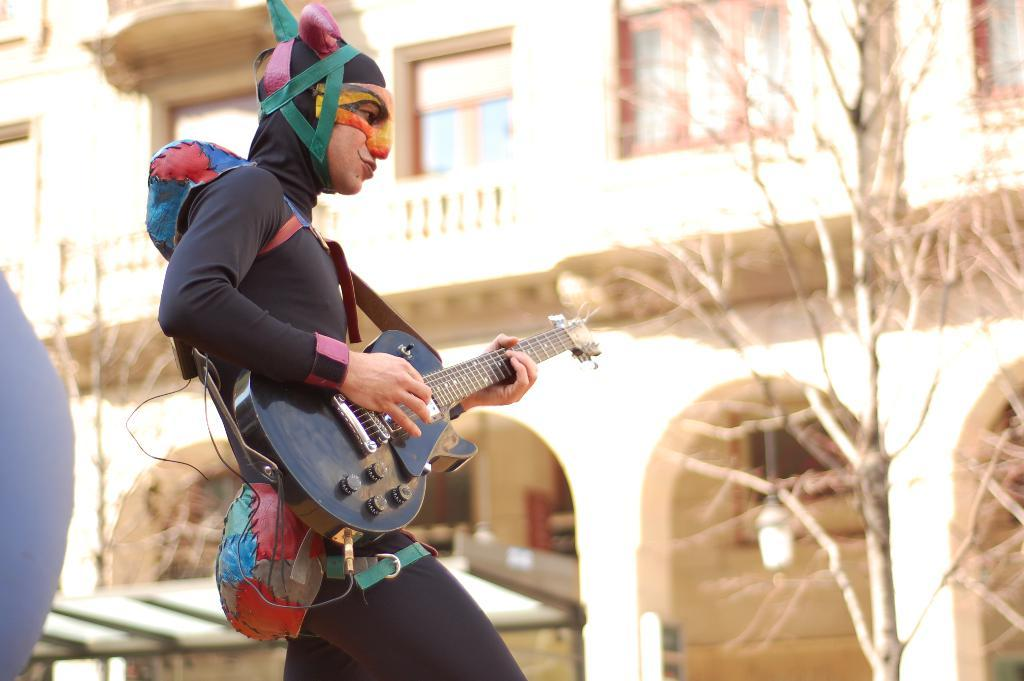What type of structure is visible in the image? There is a building in the image. What is the condition of the tree in the image? There is a dry tree in the image. What is the man in the image holding? The man in the image is holding a guitar. Can you tell me how many partners the man with the guitar has in the image? There is no mention of a partner or any relationship between the man and others in the image. The man is simply holding a guitar. Is there a kissing scene between the man and the tree in the image? No, there is no kissing scene in the image. The man is holding a guitar, and the tree is dry and not interacting with the man. 